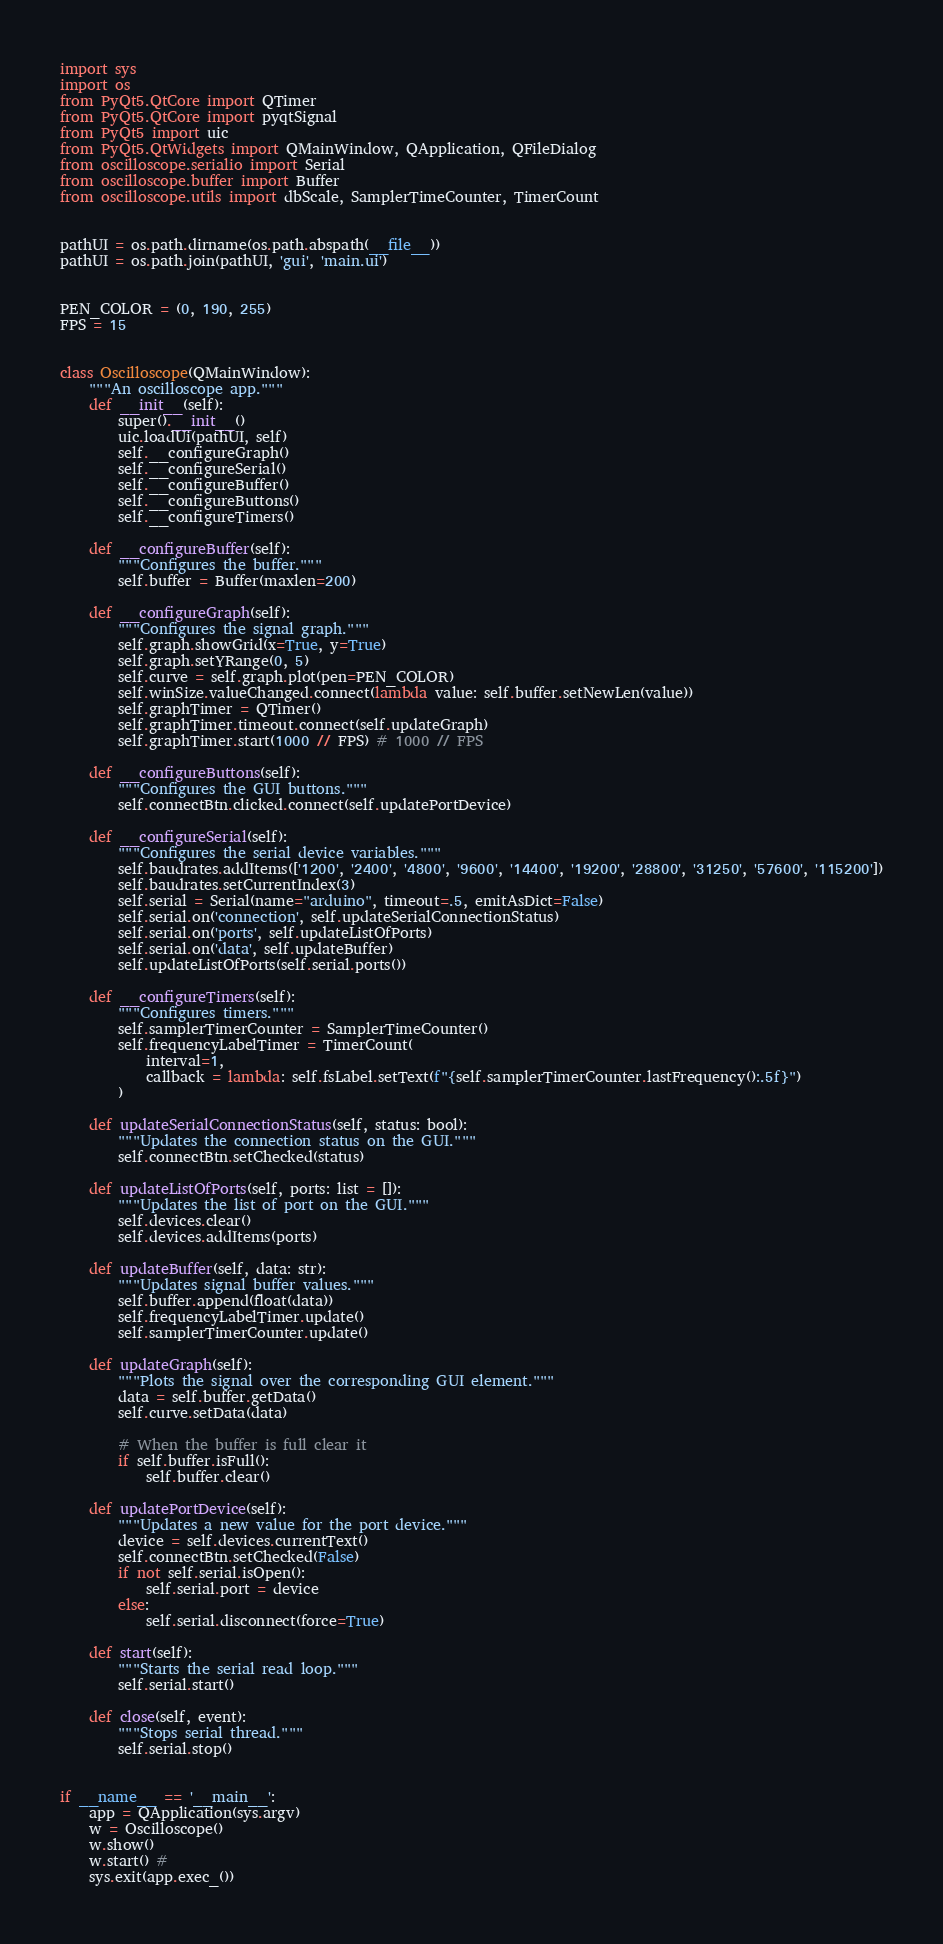<code> <loc_0><loc_0><loc_500><loc_500><_Python_>import sys
import os
from PyQt5.QtCore import QTimer
from PyQt5.QtCore import pyqtSignal
from PyQt5 import uic
from PyQt5.QtWidgets import QMainWindow, QApplication, QFileDialog
from oscilloscope.serialio import Serial
from oscilloscope.buffer import Buffer
from oscilloscope.utils import dbScale, SamplerTimeCounter, TimerCount


pathUI = os.path.dirname(os.path.abspath(__file__))
pathUI = os.path.join(pathUI, 'gui', 'main.ui')


PEN_COLOR = (0, 190, 255)
FPS = 15


class Oscilloscope(QMainWindow):
    """An oscilloscope app."""
    def __init__(self):
        super().__init__()
        uic.loadUi(pathUI, self)
        self.__configureGraph()
        self.__configureSerial()
        self.__configureBuffer()
        self.__configureButtons()
        self.__configureTimers()

    def __configureBuffer(self):
        """Configures the buffer."""
        self.buffer = Buffer(maxlen=200)

    def __configureGraph(self):
        """Configures the signal graph."""
        self.graph.showGrid(x=True, y=True)
        self.graph.setYRange(0, 5)
        self.curve = self.graph.plot(pen=PEN_COLOR)
        self.winSize.valueChanged.connect(lambda value: self.buffer.setNewLen(value))
        self.graphTimer = QTimer()
        self.graphTimer.timeout.connect(self.updateGraph)
        self.graphTimer.start(1000 // FPS) # 1000 // FPS

    def __configureButtons(self):
        """Configures the GUI buttons."""
        self.connectBtn.clicked.connect(self.updatePortDevice)

    def __configureSerial(self):
        """Configures the serial device variables."""
        self.baudrates.addItems(['1200', '2400', '4800', '9600', '14400', '19200', '28800', '31250', '57600', '115200'])
        self.baudrates.setCurrentIndex(3)
        self.serial = Serial(name="arduino", timeout=.5, emitAsDict=False)
        self.serial.on('connection', self.updateSerialConnectionStatus)
        self.serial.on('ports', self.updateListOfPorts)
        self.serial.on('data', self.updateBuffer)
        self.updateListOfPorts(self.serial.ports())

    def __configureTimers(self):
        """Configures timers."""
        self.samplerTimerCounter = SamplerTimeCounter()
        self.frequencyLabelTimer = TimerCount(
            interval=1, 
            callback = lambda: self.fsLabel.setText(f"{self.samplerTimerCounter.lastFrequency():.5f}")
        )

    def updateSerialConnectionStatus(self, status: bool):
        """Updates the connection status on the GUI."""
        self.connectBtn.setChecked(status)

    def updateListOfPorts(self, ports: list = []):
        """Updates the list of port on the GUI."""
        self.devices.clear()
        self.devices.addItems(ports)

    def updateBuffer(self, data: str):
        """Updates signal buffer values."""
        self.buffer.append(float(data))
        self.frequencyLabelTimer.update()
        self.samplerTimerCounter.update()

    def updateGraph(self):   
        """Plots the signal over the corresponding GUI element."""    
        data = self.buffer.getData()
        self.curve.setData(data)

        # When the buffer is full clear it
        if self.buffer.isFull():
            self.buffer.clear()
        
    def updatePortDevice(self):
        """Updates a new value for the port device."""
        device = self.devices.currentText()
        self.connectBtn.setChecked(False)
        if not self.serial.isOpen():
            self.serial.port = device
        else:
            self.serial.disconnect(force=True)
    
    def start(self):
        """Starts the serial read loop."""
        self.serial.start()

    def close(self, event):
        """Stops serial thread."""
        self.serial.stop()


if __name__ == '__main__':
    app = QApplication(sys.argv)
    w = Oscilloscope()
    w.show()
    w.start() # 
    sys.exit(app.exec_())
</code> 